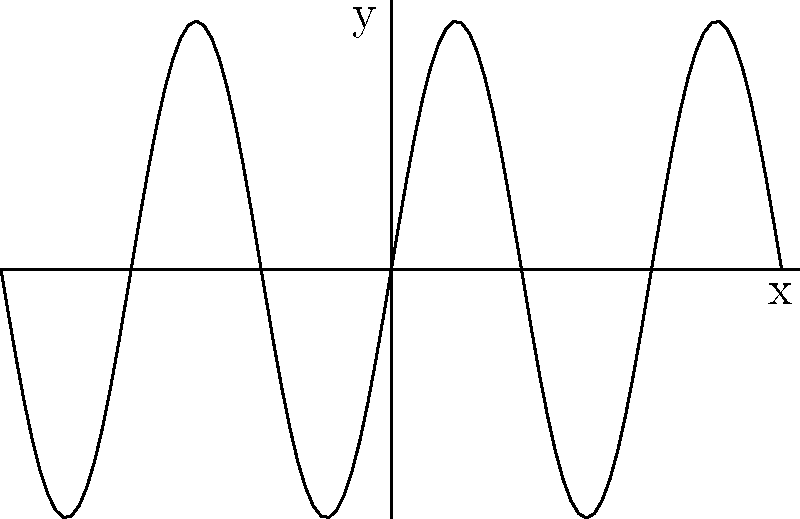Given the sine wave shown in the graph, determine the amplitude and frequency of the function $f(x) = A \sin(Bx)$, where $A$ represents the amplitude and $B$ represents the angular frequency. To determine the amplitude and frequency of the given sine wave, we need to analyze the graph:

1. Amplitude (A):
   - The amplitude is the maximum vertical distance from the midline to the peak or trough of the wave.
   - From the graph, we can see that the wave oscillates between -2 and 2.
   - Therefore, the amplitude A = 2.

2. Angular Frequency (B):
   - The angular frequency determines how many cycles the wave completes in a given interval.
   - We can observe that the wave completes 3 full cycles within the interval [-π, π].
   - For a standard sine function, one cycle is completed in 2π radians.
   - So, we have: $3 * \frac{2\pi}{B} = 2\pi$
   - Solving for B: $B = 3$

Therefore, the function can be written as $f(x) = 2 \sin(3x)$.
Answer: $A = 2, B = 3$ 